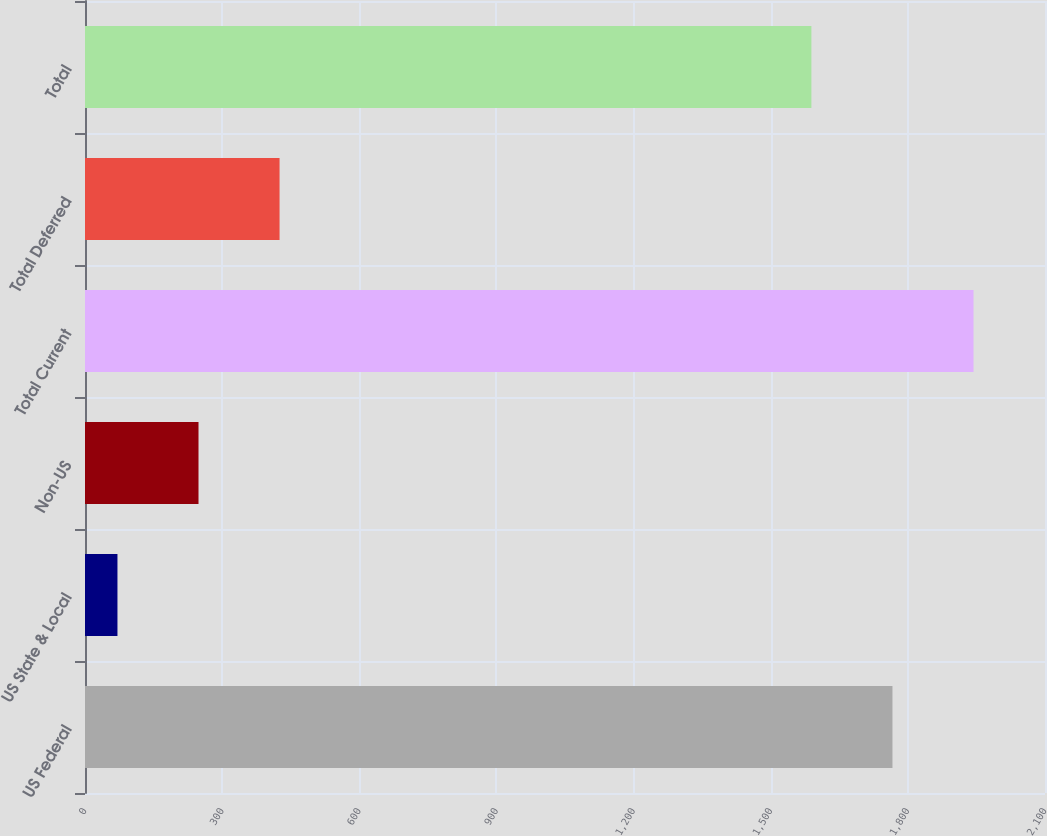Convert chart. <chart><loc_0><loc_0><loc_500><loc_500><bar_chart><fcel>US Federal<fcel>US State & Local<fcel>Non-US<fcel>Total Current<fcel>Total Deferred<fcel>Total<nl><fcel>1766.3<fcel>71<fcel>248.3<fcel>1943.6<fcel>425.6<fcel>1589<nl></chart> 